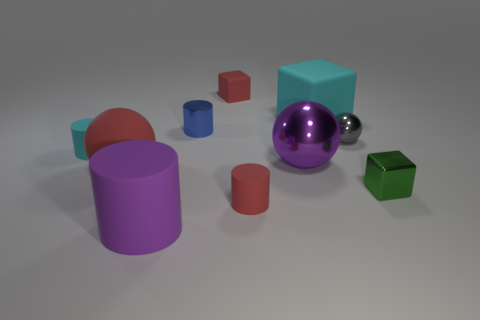Subtract all blue cylinders. How many cylinders are left? 3 Subtract 1 cubes. How many cubes are left? 2 Subtract all shiny spheres. How many spheres are left? 1 Subtract all cylinders. How many objects are left? 6 Add 3 tiny gray metallic objects. How many tiny gray metallic objects are left? 4 Add 3 small blue things. How many small blue things exist? 4 Subtract 1 gray balls. How many objects are left? 9 Subtract all gray blocks. Subtract all blue spheres. How many blocks are left? 3 Subtract all big brown objects. Subtract all big purple rubber objects. How many objects are left? 9 